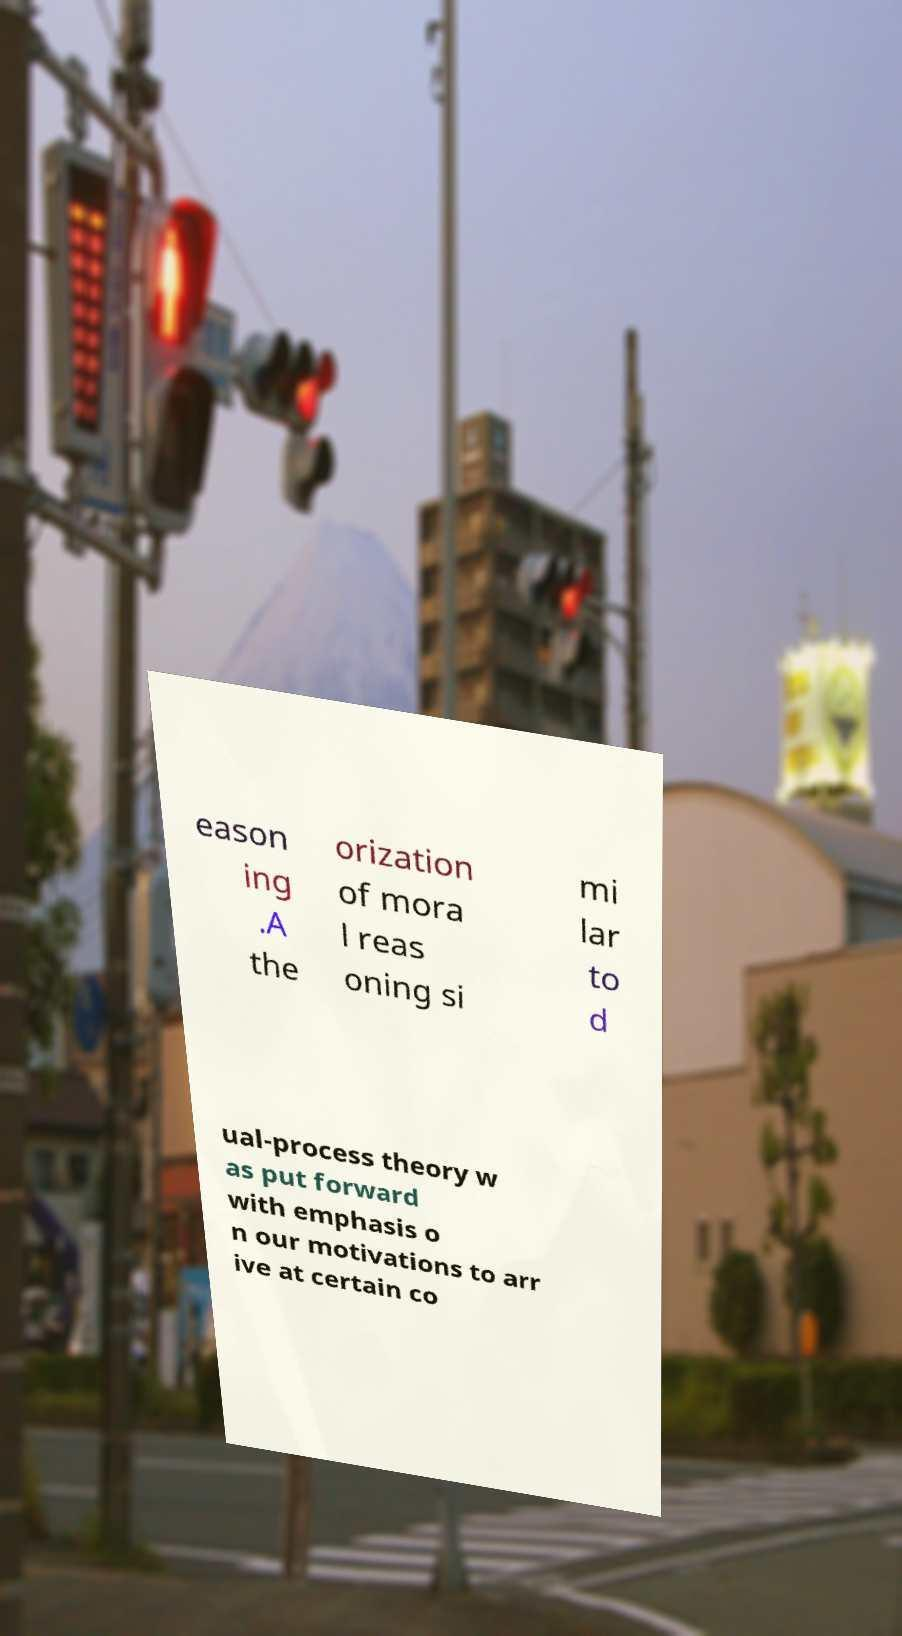Please read and relay the text visible in this image. What does it say? eason ing .A the orization of mora l reas oning si mi lar to d ual-process theory w as put forward with emphasis o n our motivations to arr ive at certain co 